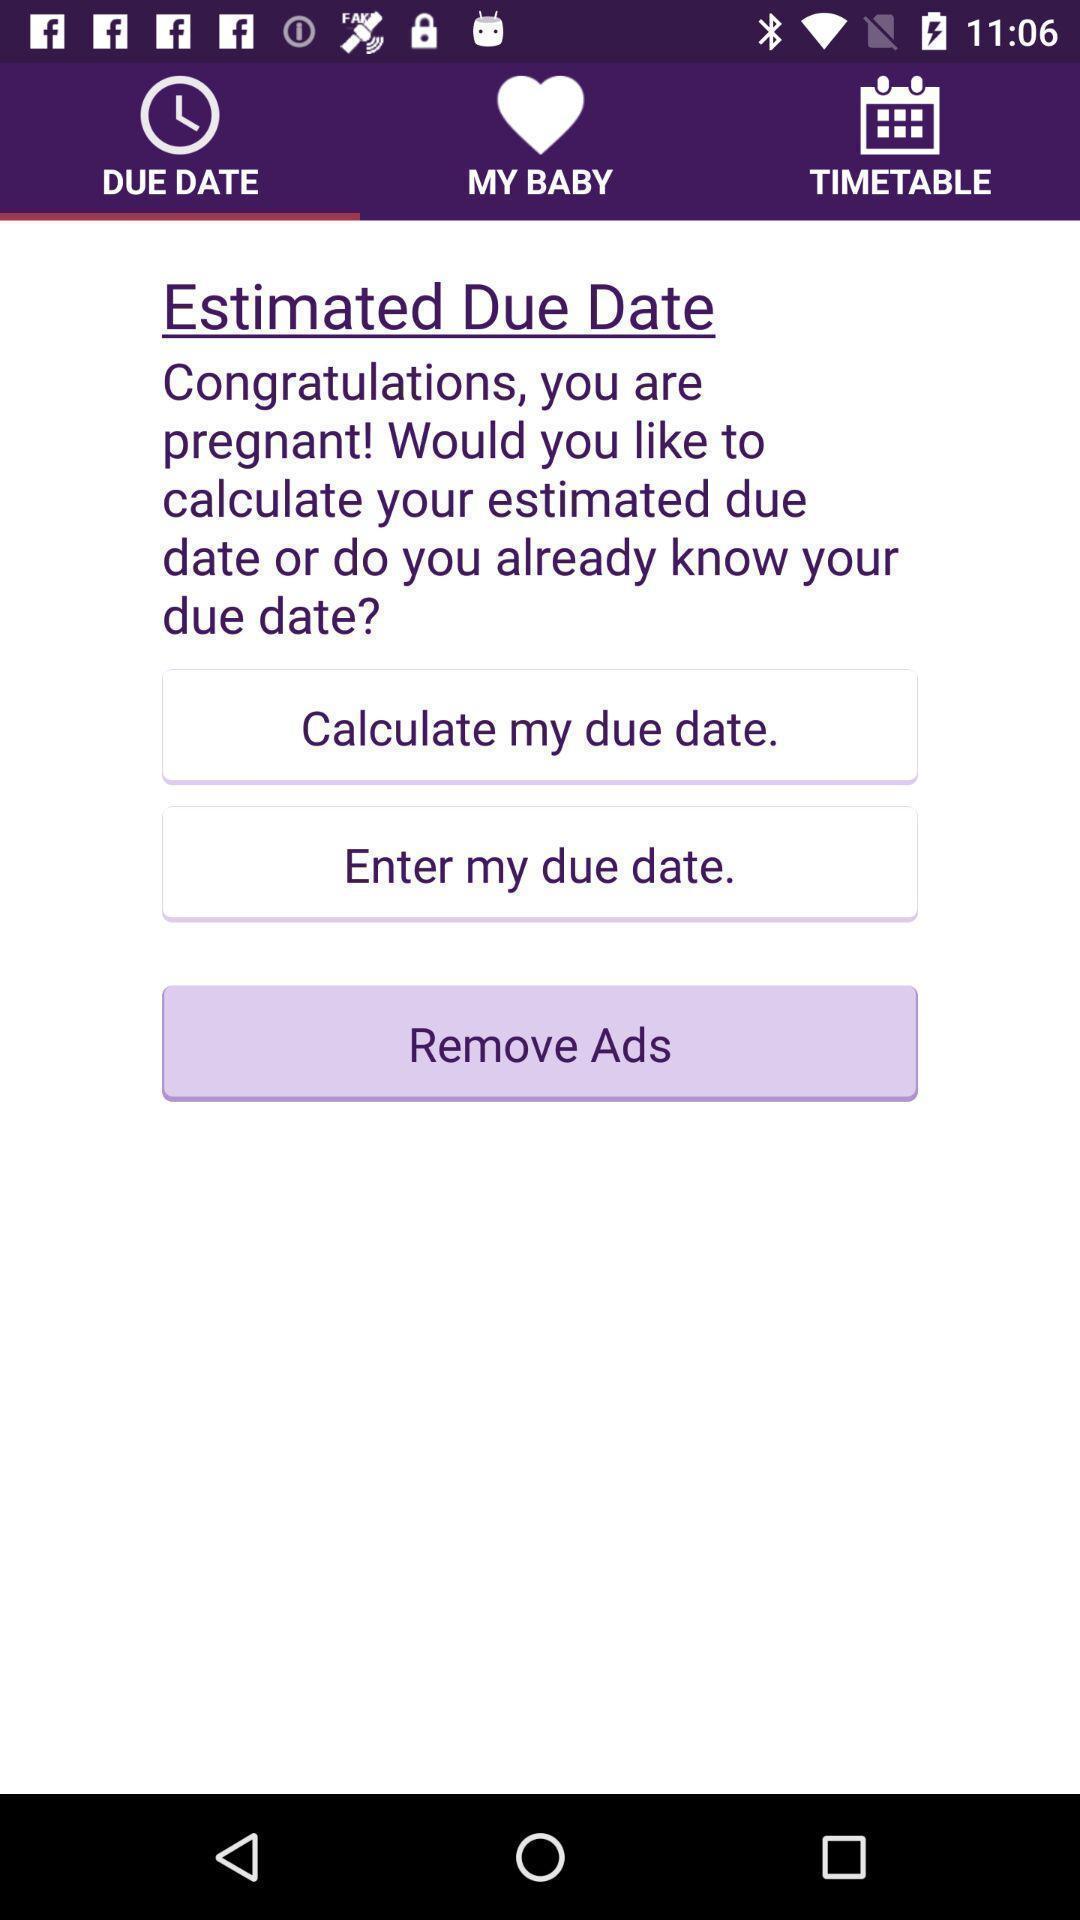Provide a description of this screenshot. Screen page displaying different options. 